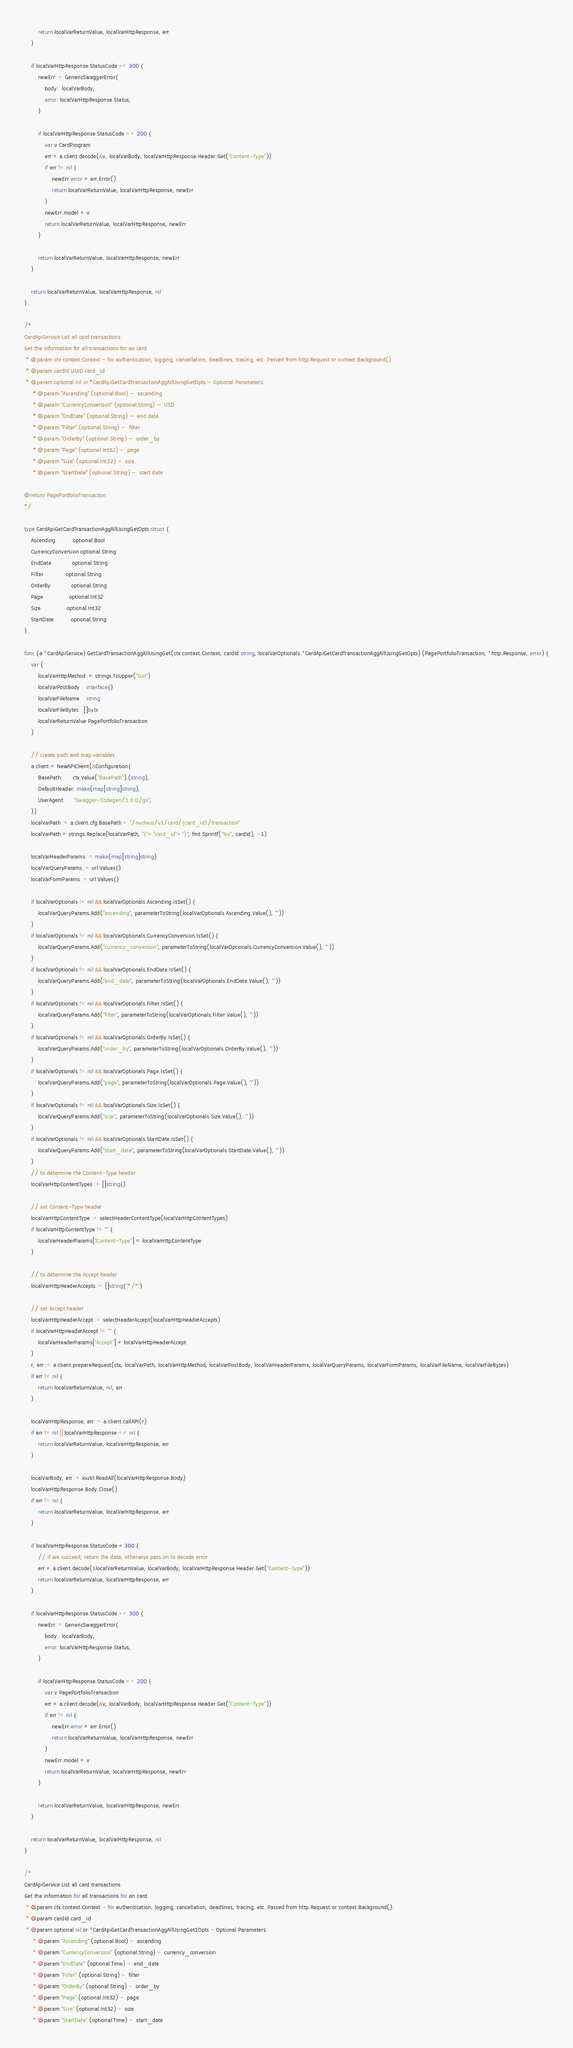<code> <loc_0><loc_0><loc_500><loc_500><_Go_>		return localVarReturnValue, localVarHttpResponse, err
	}

	if localVarHttpResponse.StatusCode >= 300 {
		newErr := GenericSwaggerError{
			body:  localVarBody,
			error: localVarHttpResponse.Status,
		}

		if localVarHttpResponse.StatusCode == 200 {
			var v CardProgram
			err = a.client.decode(&v, localVarBody, localVarHttpResponse.Header.Get("Content-Type"))
			if err != nil {
				newErr.error = err.Error()
				return localVarReturnValue, localVarHttpResponse, newErr
			}
			newErr.model = v
			return localVarReturnValue, localVarHttpResponse, newErr
		}

		return localVarReturnValue, localVarHttpResponse, newErr
	}

	return localVarReturnValue, localVarHttpResponse, nil
}

/*
CardApiService List all card transactions
Get the information for all transactions for an card.
 * @param ctx context.Context - for authentication, logging, cancellation, deadlines, tracing, etc. Passed from http.Request or context.Background().
 * @param cardId UUID card_id
 * @param optional nil or *CardApiGetCardTransactionAggAllUsingGetOpts - Optional Parameters:
     * @param "Ascending" (optional.Bool) -  ascending
     * @param "CurrencyConversion" (optional.String) -  USD
     * @param "EndDate" (optional.String) -  end date
     * @param "Filter" (optional.String) -  filter
     * @param "OrderBy" (optional.String) -  order_by
     * @param "Page" (optional.Int32) -  page
     * @param "Size" (optional.Int32) -  size
     * @param "StartDate" (optional.String) -  start date

@return PagePortfolioTransaction
*/

type CardApiGetCardTransactionAggAllUsingGetOpts struct {
	Ascending          optional.Bool
	CurrencyConversion optional.String
	EndDate            optional.String
	Filter             optional.String
	OrderBy            optional.String
	Page               optional.Int32
	Size               optional.Int32
	StartDate          optional.String
}

func (a *CardApiService) GetCardTransactionAggAllUsingGet(ctx context.Context, cardId string, localVarOptionals *CardApiGetCardTransactionAggAllUsingGetOpts) (PagePortfolioTransaction, *http.Response, error) {
	var (
		localVarHttpMethod  = strings.ToUpper("Get")
		localVarPostBody    interface{}
		localVarFileName    string
		localVarFileBytes   []byte
		localVarReturnValue PagePortfolioTransaction
	)

	// create path and map variables
	a.client = NewAPIClient(&Configuration{
		BasePath:      ctx.Value("BasePath").(string),
		DefaultHeader: make(map[string]string),
		UserAgent:     "Swagger-Codegen/1.0.0/go",
	})
	localVarPath := a.client.cfg.BasePath + "/nucleus/v1/card/{card_id}/transaction"
	localVarPath = strings.Replace(localVarPath, "{"+"card_id"+"}", fmt.Sprintf("%v", cardId), -1)

	localVarHeaderParams := make(map[string]string)
	localVarQueryParams := url.Values{}
	localVarFormParams := url.Values{}

	if localVarOptionals != nil && localVarOptionals.Ascending.IsSet() {
		localVarQueryParams.Add("ascending", parameterToString(localVarOptionals.Ascending.Value(), ""))
	}
	if localVarOptionals != nil && localVarOptionals.CurrencyConversion.IsSet() {
		localVarQueryParams.Add("currency_conversion", parameterToString(localVarOptionals.CurrencyConversion.Value(), ""))
	}
	if localVarOptionals != nil && localVarOptionals.EndDate.IsSet() {
		localVarQueryParams.Add("end_date", parameterToString(localVarOptionals.EndDate.Value(), ""))
	}
	if localVarOptionals != nil && localVarOptionals.Filter.IsSet() {
		localVarQueryParams.Add("filter", parameterToString(localVarOptionals.Filter.Value(), ""))
	}
	if localVarOptionals != nil && localVarOptionals.OrderBy.IsSet() {
		localVarQueryParams.Add("order_by", parameterToString(localVarOptionals.OrderBy.Value(), ""))
	}
	if localVarOptionals != nil && localVarOptionals.Page.IsSet() {
		localVarQueryParams.Add("page", parameterToString(localVarOptionals.Page.Value(), ""))
	}
	if localVarOptionals != nil && localVarOptionals.Size.IsSet() {
		localVarQueryParams.Add("size", parameterToString(localVarOptionals.Size.Value(), ""))
	}
	if localVarOptionals != nil && localVarOptionals.StartDate.IsSet() {
		localVarQueryParams.Add("start_date", parameterToString(localVarOptionals.StartDate.Value(), ""))
	}
	// to determine the Content-Type header
	localVarHttpContentTypes := []string{}

	// set Content-Type header
	localVarHttpContentType := selectHeaderContentType(localVarHttpContentTypes)
	if localVarHttpContentType != "" {
		localVarHeaderParams["Content-Type"] = localVarHttpContentType
	}

	// to determine the Accept header
	localVarHttpHeaderAccepts := []string{"*/*"}

	// set Accept header
	localVarHttpHeaderAccept := selectHeaderAccept(localVarHttpHeaderAccepts)
	if localVarHttpHeaderAccept != "" {
		localVarHeaderParams["Accept"] = localVarHttpHeaderAccept
	}
	r, err := a.client.prepareRequest(ctx, localVarPath, localVarHttpMethod, localVarPostBody, localVarHeaderParams, localVarQueryParams, localVarFormParams, localVarFileName, localVarFileBytes)
	if err != nil {
		return localVarReturnValue, nil, err
	}

	localVarHttpResponse, err := a.client.callAPI(r)
	if err != nil || localVarHttpResponse == nil {
		return localVarReturnValue, localVarHttpResponse, err
	}

	localVarBody, err := ioutil.ReadAll(localVarHttpResponse.Body)
	localVarHttpResponse.Body.Close()
	if err != nil {
		return localVarReturnValue, localVarHttpResponse, err
	}

	if localVarHttpResponse.StatusCode < 300 {
		// If we succeed, return the data, otherwise pass on to decode error.
		err = a.client.decode(&localVarReturnValue, localVarBody, localVarHttpResponse.Header.Get("Content-Type"))
		return localVarReturnValue, localVarHttpResponse, err
	}

	if localVarHttpResponse.StatusCode >= 300 {
		newErr := GenericSwaggerError{
			body:  localVarBody,
			error: localVarHttpResponse.Status,
		}

		if localVarHttpResponse.StatusCode == 200 {
			var v PagePortfolioTransaction
			err = a.client.decode(&v, localVarBody, localVarHttpResponse.Header.Get("Content-Type"))
			if err != nil {
				newErr.error = err.Error()
				return localVarReturnValue, localVarHttpResponse, newErr
			}
			newErr.model = v
			return localVarReturnValue, localVarHttpResponse, newErr
		}

		return localVarReturnValue, localVarHttpResponse, newErr
	}

	return localVarReturnValue, localVarHttpResponse, nil
}

/*
CardApiService List all card transactions
Get the information for all transactions for an card.
 * @param ctx context.Context - for authentication, logging, cancellation, deadlines, tracing, etc. Passed from http.Request or context.Background().
 * @param cardId card_id
 * @param optional nil or *CardApiGetCardTransactionAggAllUsingGet1Opts - Optional Parameters:
     * @param "Ascending" (optional.Bool) -  ascending
     * @param "CurrencyConversion" (optional.String) -  currency_conversion
     * @param "EndDate" (optional.Time) -  end_date
     * @param "Filter" (optional.String) -  filter
     * @param "OrderBy" (optional.String) -  order_by
     * @param "Page" (optional.Int32) -  page
     * @param "Size" (optional.Int32) -  size
     * @param "StartDate" (optional.Time) -  start_date
</code> 